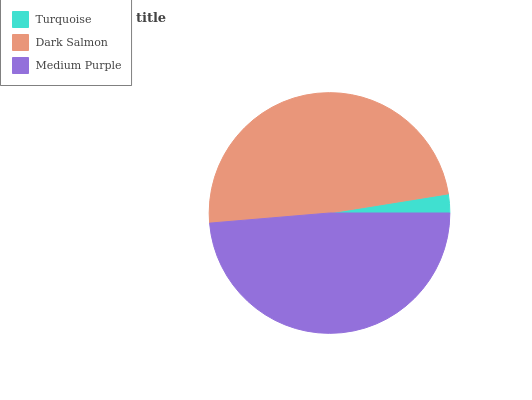Is Turquoise the minimum?
Answer yes or no. Yes. Is Dark Salmon the maximum?
Answer yes or no. Yes. Is Medium Purple the minimum?
Answer yes or no. No. Is Medium Purple the maximum?
Answer yes or no. No. Is Dark Salmon greater than Medium Purple?
Answer yes or no. Yes. Is Medium Purple less than Dark Salmon?
Answer yes or no. Yes. Is Medium Purple greater than Dark Salmon?
Answer yes or no. No. Is Dark Salmon less than Medium Purple?
Answer yes or no. No. Is Medium Purple the high median?
Answer yes or no. Yes. Is Medium Purple the low median?
Answer yes or no. Yes. Is Turquoise the high median?
Answer yes or no. No. Is Dark Salmon the low median?
Answer yes or no. No. 